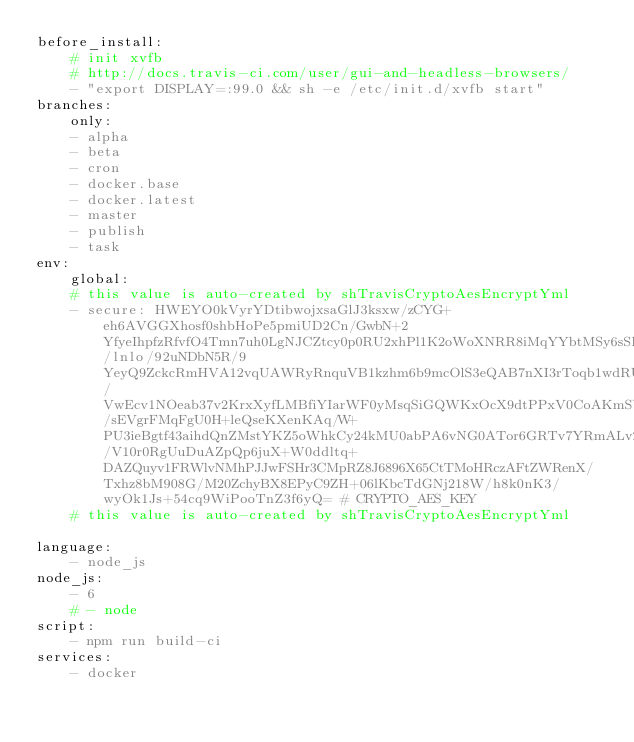Convert code to text. <code><loc_0><loc_0><loc_500><loc_500><_YAML_>before_install:
    # init xvfb
    # http://docs.travis-ci.com/user/gui-and-headless-browsers/
    - "export DISPLAY=:99.0 && sh -e /etc/init.d/xvfb start"
branches:
    only:
    - alpha
    - beta
    - cron
    - docker.base
    - docker.latest
    - master
    - publish
    - task
env:
    global:
    # this value is auto-created by shTravisCryptoAesEncryptYml
    - secure: HWEYO0kVyrYDtibwojxsaGlJ3ksxw/zCYG+eh6AVGGXhosf0shbHoPe5pmiUD2Cn/GwbN+2YfyeIhpfzRfvfO4Tmn7uh0LgNJCZtcy0p0RU2xhPl1K2oWoXNRR8iMqYYbtMSy6sSHGRlfnoPUGQgl6yMVO8haNHvs7qXxNdz4kEc0PyMC37T8HWzGwTYLHFmHz/lnlo/92uNDbN5R/9YeyQ9ZckcRmHVA12vqUAWRyRnquVB1kzhm6b9mcOlS3eQAB7nXI3rToqb1wdRUOKjD4ZcP6OIm35WB38jLaxhlU10HJ8tsqiyDXntixqHmVgLAc8RL6w/VwEcv1NOeab37v2KrxXyfLMBfiYIarWF0yMsqSiGQWKxOcX9dtPPxV0CoAKmSW31cBbs5j9hLLi3lKg1Y/sEVgrFMqFgU0H+leQseKXenKAq/W+PU3ieBgtf43aihdQnZMstYKZ5oWhkCy24kMU0abPA6vNG0ATor6GRTv7YRmALv2zKaoSBTxJ244H/V10r0RgUuDuAZpQp6juX+W0ddltq+DAZQuyv1FRWlvNMhPJJwFSHr3CMpRZ8J6896X65CtTMoHRczAFtZWRenX/Txhz8bM908G/M20ZchyBX8EPyC9ZH+06lKbcTdGNj218W/h8k0nK3/wyOk1Js+54cq9WiPooTnZ3f6yQ= # CRYPTO_AES_KEY
    # this value is auto-created by shTravisCryptoAesEncryptYml

language:
    - node_js
node_js:
    - 6
    # - node
script:
    - npm run build-ci
services:
    - docker</code> 